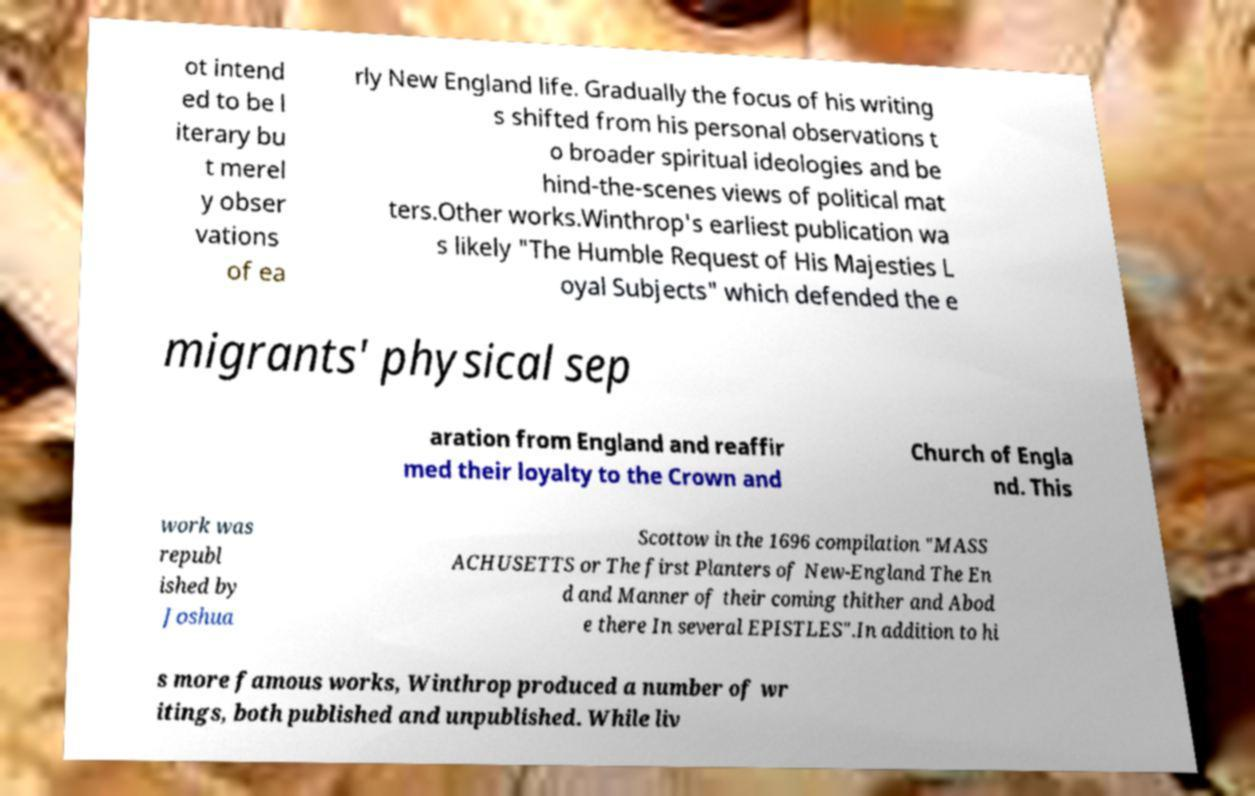For documentation purposes, I need the text within this image transcribed. Could you provide that? ot intend ed to be l iterary bu t merel y obser vations of ea rly New England life. Gradually the focus of his writing s shifted from his personal observations t o broader spiritual ideologies and be hind-the-scenes views of political mat ters.Other works.Winthrop's earliest publication wa s likely "The Humble Request of His Majesties L oyal Subjects" which defended the e migrants' physical sep aration from England and reaffir med their loyalty to the Crown and Church of Engla nd. This work was republ ished by Joshua Scottow in the 1696 compilation "MASS ACHUSETTS or The first Planters of New-England The En d and Manner of their coming thither and Abod e there In several EPISTLES".In addition to hi s more famous works, Winthrop produced a number of wr itings, both published and unpublished. While liv 